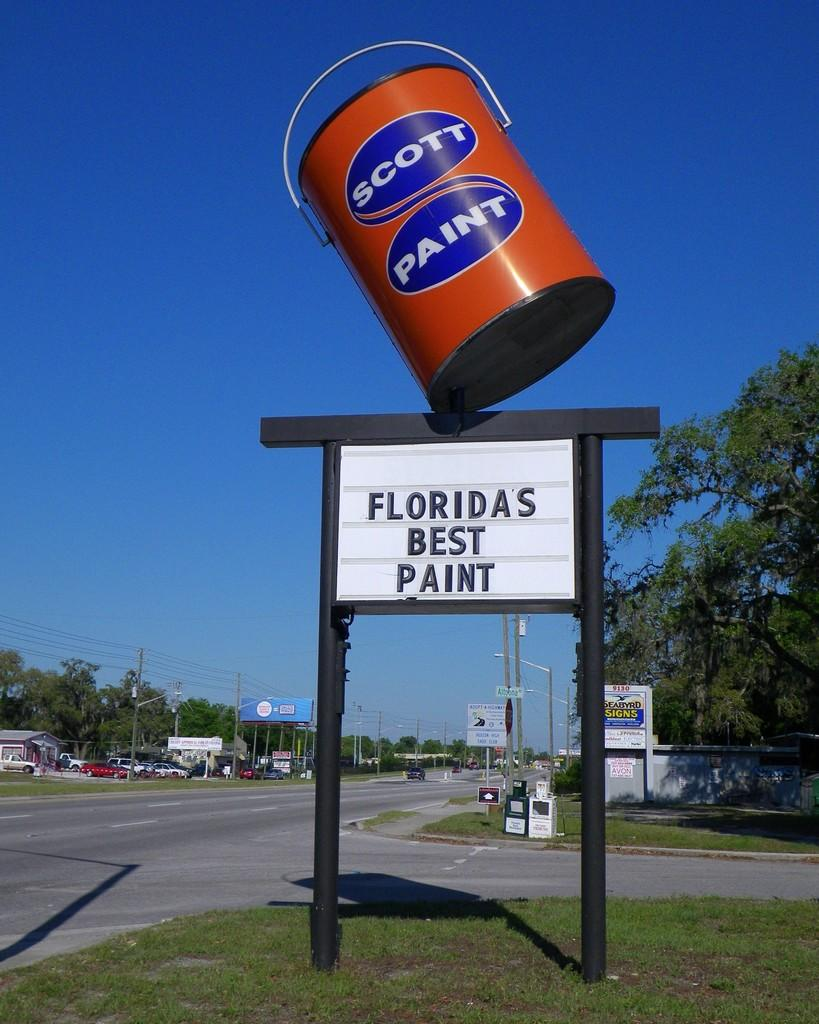Provide a one-sentence caption for the provided image. the words best paint are on the sign under the paint can. 